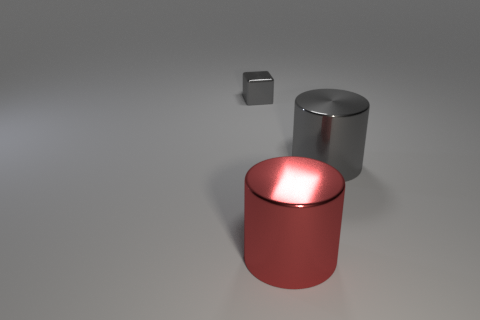There is a big cylinder that is behind the big red shiny thing; what is its material?
Offer a very short reply. Metal. There is a gray shiny object to the right of the large object in front of the gray object to the right of the metal cube; what is its size?
Offer a very short reply. Large. Is the cube that is behind the big red cylinder made of the same material as the large cylinder that is in front of the gray shiny cylinder?
Your answer should be very brief. Yes. How many other objects are the same color as the tiny shiny object?
Your answer should be very brief. 1. What number of things are shiny objects in front of the block or gray shiny objects that are behind the gray metallic cylinder?
Give a very brief answer. 3. How big is the gray shiny object behind the gray thing on the right side of the small gray metal cube?
Your answer should be compact. Small. What is the size of the gray shiny cylinder?
Give a very brief answer. Large. Does the large metallic thing to the right of the red object have the same color as the thing in front of the big gray shiny object?
Make the answer very short. No. What number of other things are made of the same material as the red cylinder?
Keep it short and to the point. 2. Are any purple cylinders visible?
Ensure brevity in your answer.  No. 